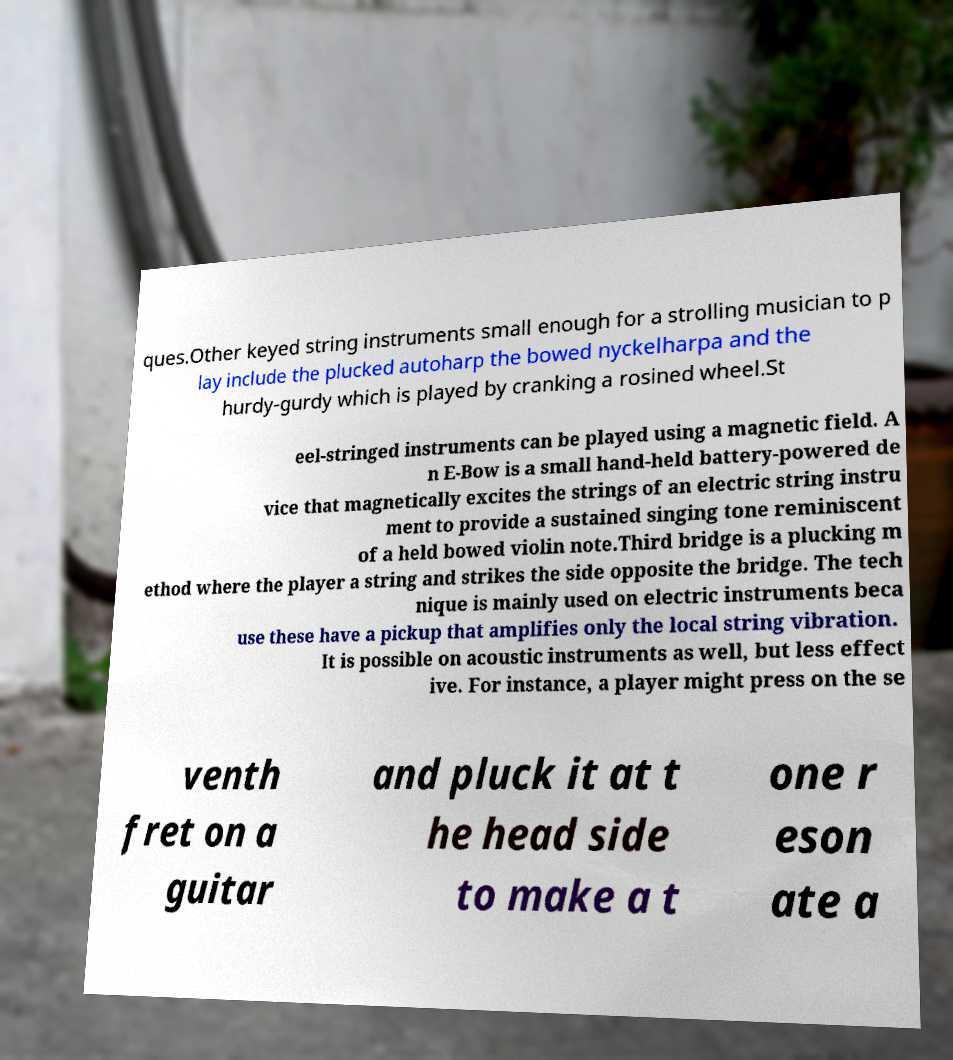Can you read and provide the text displayed in the image?This photo seems to have some interesting text. Can you extract and type it out for me? ques.Other keyed string instruments small enough for a strolling musician to p lay include the plucked autoharp the bowed nyckelharpa and the hurdy-gurdy which is played by cranking a rosined wheel.St eel-stringed instruments can be played using a magnetic field. A n E-Bow is a small hand-held battery-powered de vice that magnetically excites the strings of an electric string instru ment to provide a sustained singing tone reminiscent of a held bowed violin note.Third bridge is a plucking m ethod where the player a string and strikes the side opposite the bridge. The tech nique is mainly used on electric instruments beca use these have a pickup that amplifies only the local string vibration. It is possible on acoustic instruments as well, but less effect ive. For instance, a player might press on the se venth fret on a guitar and pluck it at t he head side to make a t one r eson ate a 